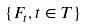<formula> <loc_0><loc_0><loc_500><loc_500>\{ F _ { t } , t \in T \}</formula> 